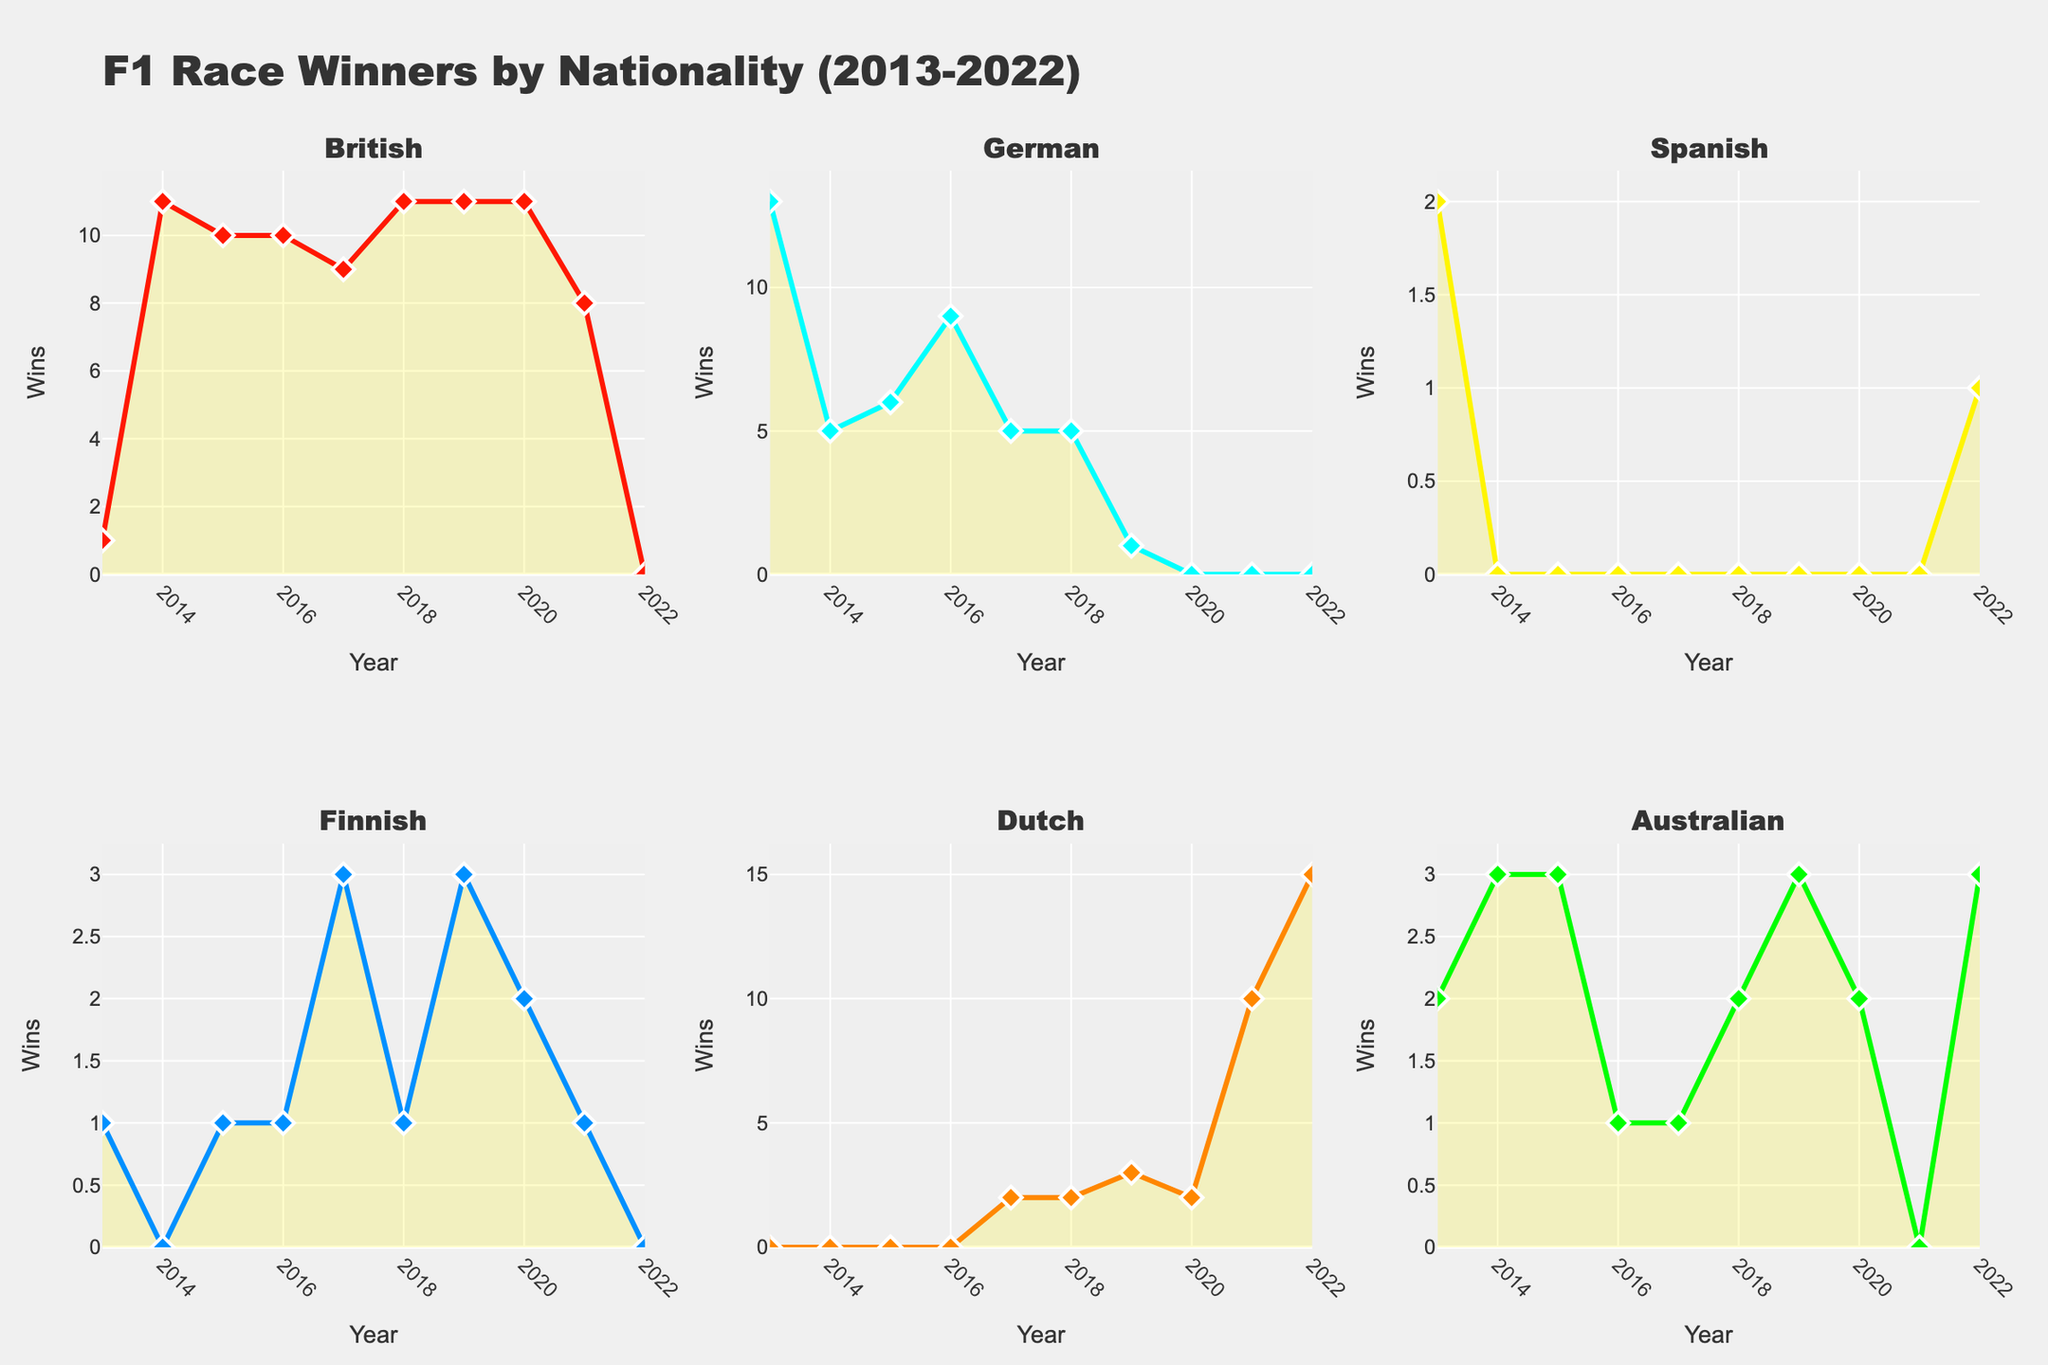What nationality has the highest number of wins in 2014? Look at the year 2014 and check each subplot to see the tallest filled area above the year 2014. The British nationality has the highest number of wins.
Answer: British Which nationality had a decreasing trend in wins from 2018 to 2020? Compare the trend lines in the subplots from 2018 to 2020. The British nationality shows a decrease in wins over that time period.
Answer: British How many wins did the Australian nationality accumulate in 2013 and 2022 combined? Check the values for the Australian subplot for the years 2013 (2 wins) and 2022 (3 wins) and add them together.
Answer: 5 Which year did the Dutch nationality first appear in the plot with at least one win? Look at the Dutch subplot and identify the first year with a value above zero. This occurs in 2017.
Answer: 2017 Did the Finnish nationality ever achieve more than 3 wins in any given year throughout the decade? Examine the Finnish subplot and check if any of the peaks go above the value of 3 wins. No year shows more than 3 wins.
Answer: No Which nationality had a sudden spike to 15 wins in 2022? Locate the year 2022 under each nationality to see where a sudden spike reaches 15. The Dutch nationality shows this spike.
Answer: Dutch How many nationalities have data points indicating race wins every single year from 2013 to 2022? For each nationality subplot, check if it has values (above zero) in every year from 2013 to 2022. Only the British nationality has race wins in every single year.
Answer: 1 Compare the total number of wins between German and Australian nationalities in 2018. Which has more? Check the values for German (5 wins) and Australian (2 wins) subplots for the year 2018 and compare.
Answer: German How many years did the Spanish nationality have zero wins in the past decade? Check the Spanish subplot to see how many years display zero wins. Spanish nationality had zero wins for 8 years (2014-2021).
Answer: 8 In which year did the Finnish nationality achieve its highest number of wins, and what was the number? Look at the highest peak in the Finnish subplot and find the corresponding year. The highest number of wins for Finland was 3 in both 2017 and 2019.
Answer: 2017 and 2019, 3 